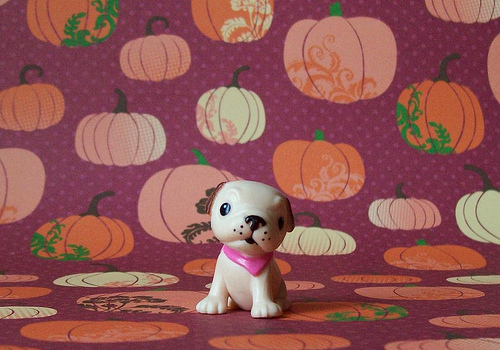<image>
Can you confirm if the dog is on the pumpkin? Yes. Looking at the image, I can see the dog is positioned on top of the pumpkin, with the pumpkin providing support. 